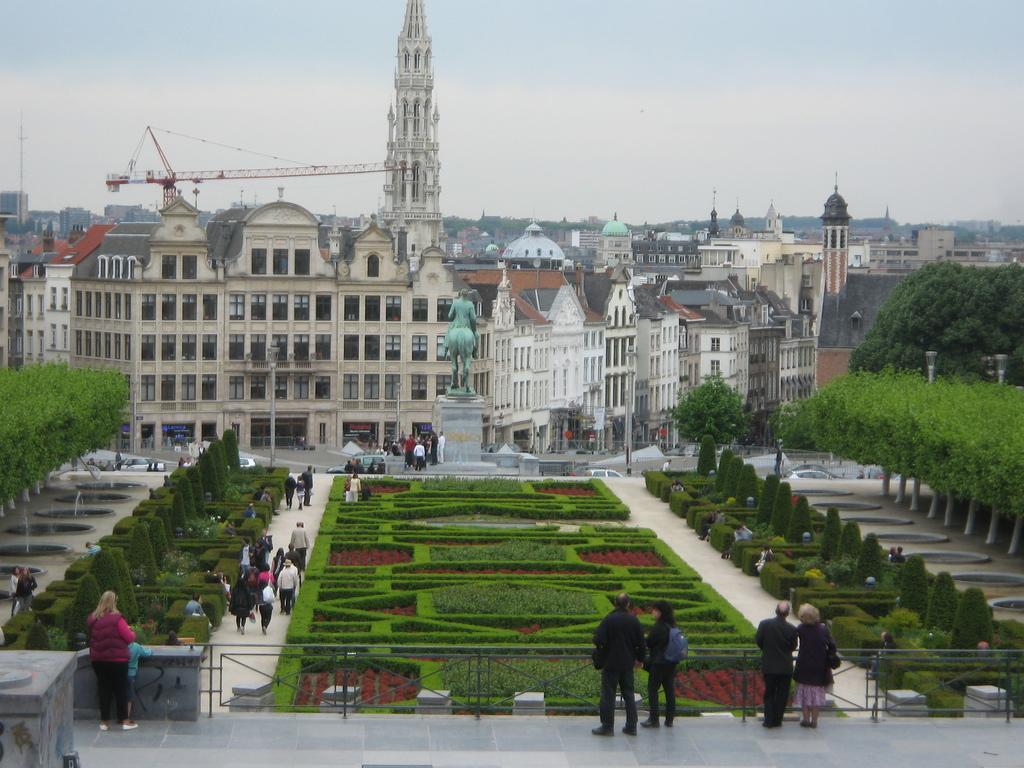Could you give a brief overview of what you see in this image? In the image we can see a group of buildings. In front of buildings we can see a statue, persons, plants and trees. At the bottom we can see a railing and few persons standing on the floor. Behind the buildings we can see a tower crane. At the top we can see the sky. 